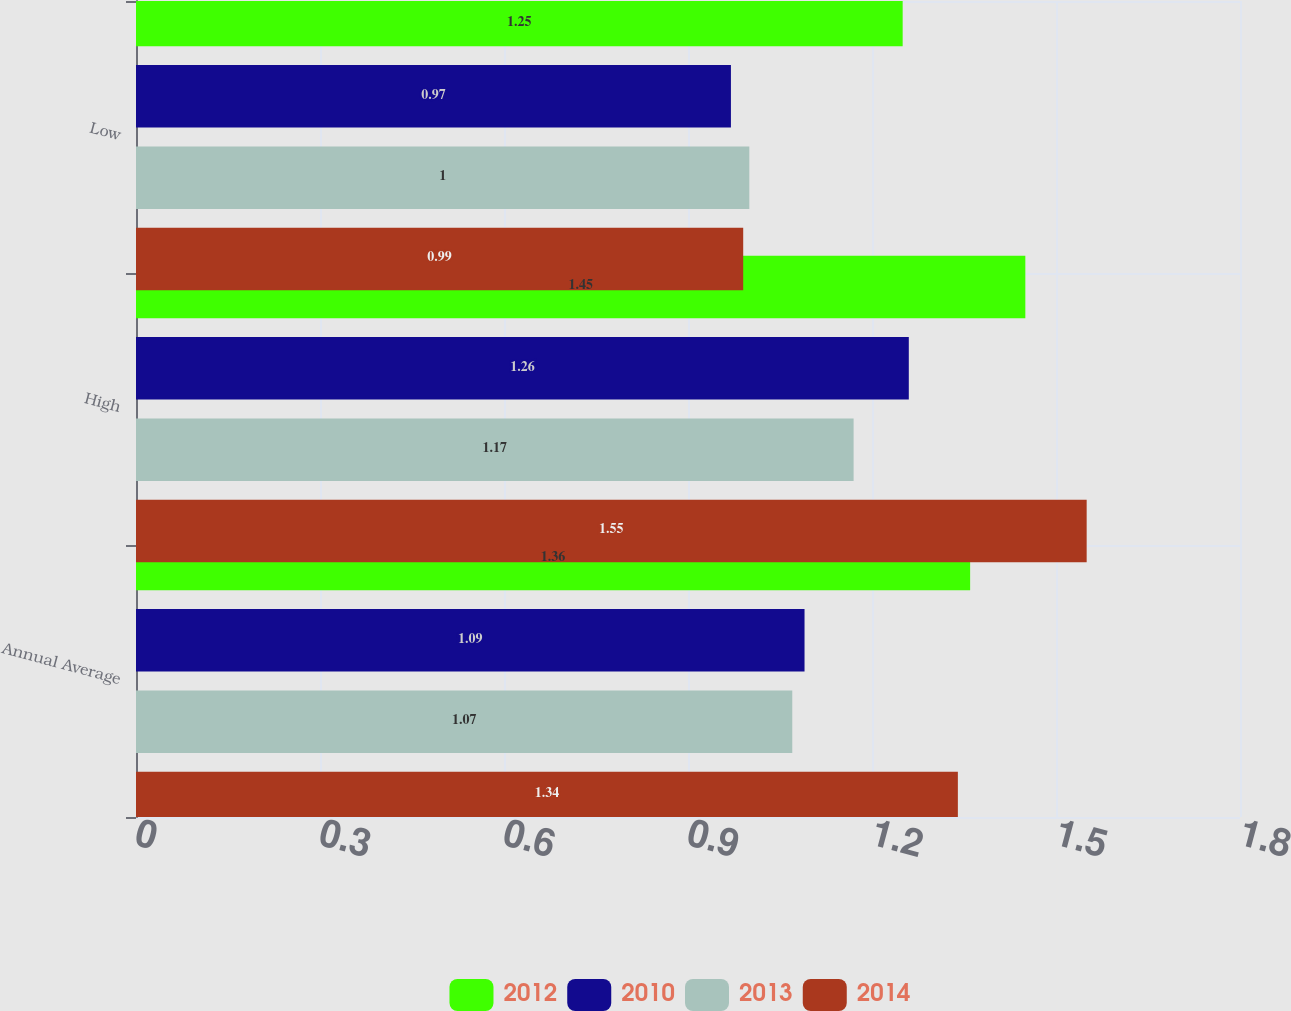<chart> <loc_0><loc_0><loc_500><loc_500><stacked_bar_chart><ecel><fcel>Annual Average<fcel>High<fcel>Low<nl><fcel>2012<fcel>1.36<fcel>1.45<fcel>1.25<nl><fcel>2010<fcel>1.09<fcel>1.26<fcel>0.97<nl><fcel>2013<fcel>1.07<fcel>1.17<fcel>1<nl><fcel>2014<fcel>1.34<fcel>1.55<fcel>0.99<nl></chart> 